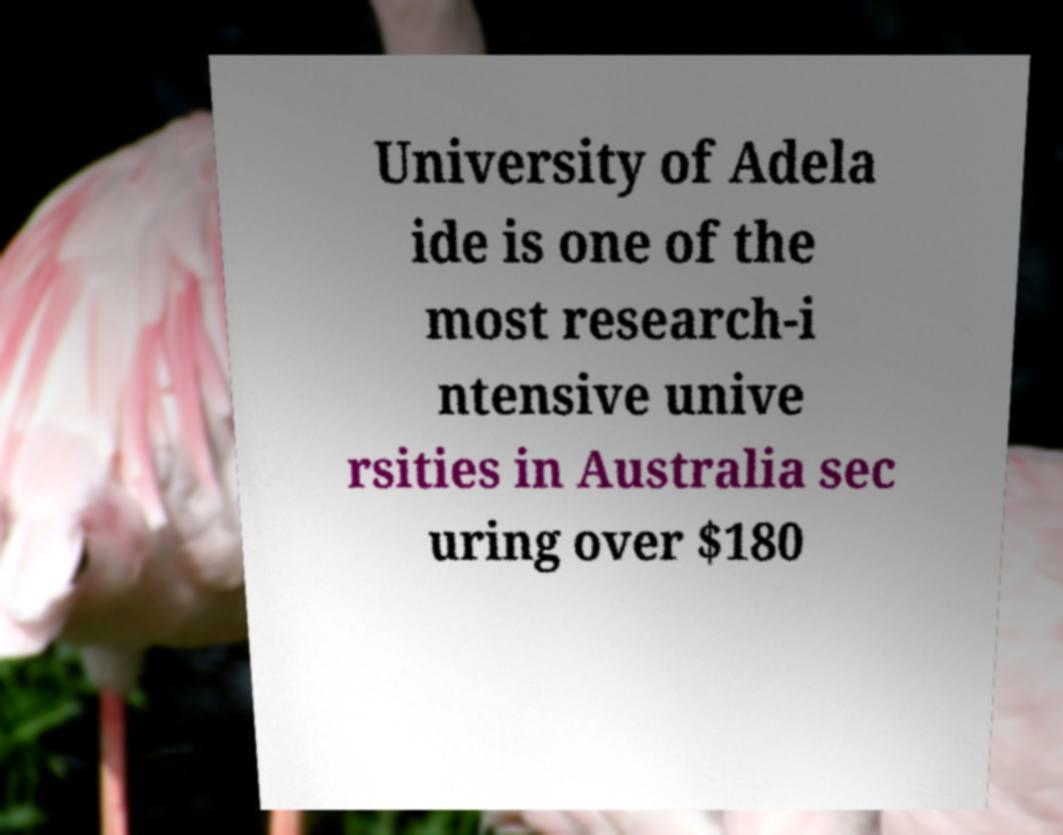I need the written content from this picture converted into text. Can you do that? University of Adela ide is one of the most research-i ntensive unive rsities in Australia sec uring over $180 